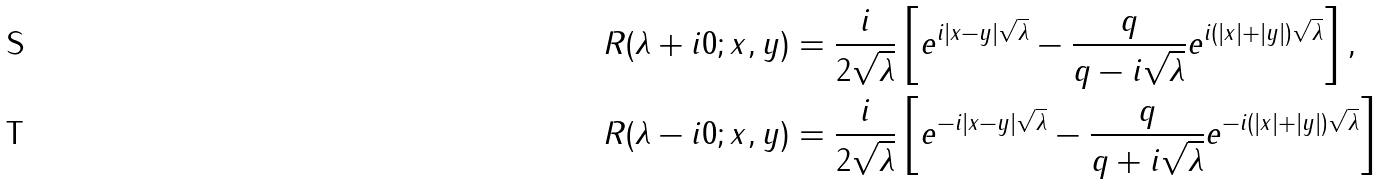<formula> <loc_0><loc_0><loc_500><loc_500>R ( \lambda + i 0 ; x , y ) & = \frac { i } { 2 \sqrt { \lambda } } \left [ e ^ { i | x - y | \sqrt { \lambda } } - \frac { q } { q - i \sqrt { \lambda } } e ^ { i ( | x | + | y | ) \sqrt { \lambda } } \right ] , \\ R ( \lambda - i 0 ; x , y ) & = \frac { i } { 2 \sqrt { \lambda } } \left [ e ^ { - i | x - y | \sqrt { \lambda } } - \frac { q } { q + i \sqrt { \lambda } } e ^ { - i ( | x | + | y | ) \sqrt { \lambda } } \right ]</formula> 